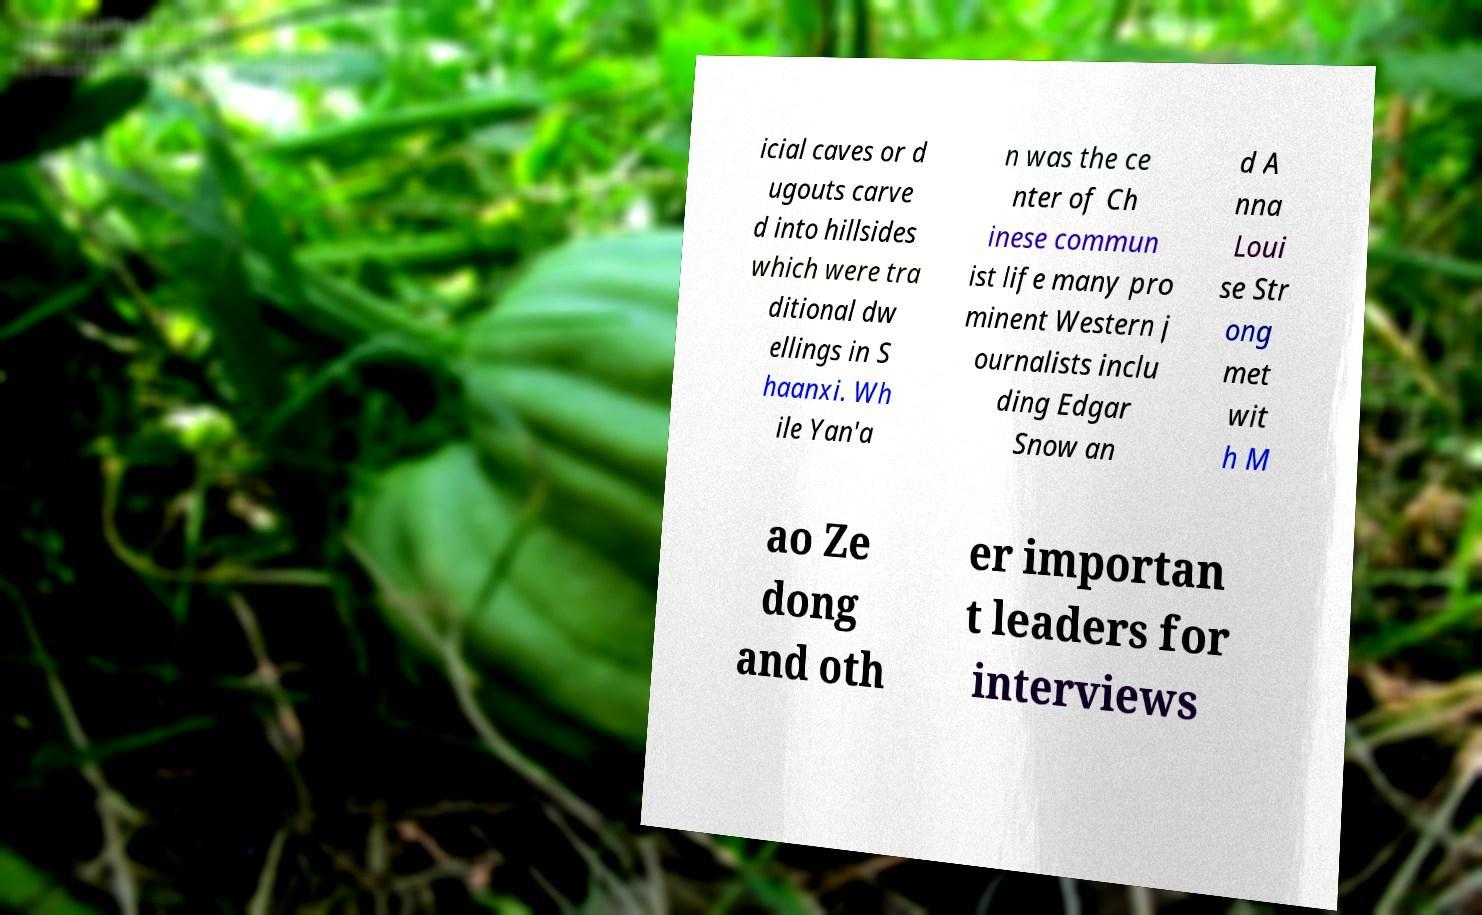Can you accurately transcribe the text from the provided image for me? icial caves or d ugouts carve d into hillsides which were tra ditional dw ellings in S haanxi. Wh ile Yan'a n was the ce nter of Ch inese commun ist life many pro minent Western j ournalists inclu ding Edgar Snow an d A nna Loui se Str ong met wit h M ao Ze dong and oth er importan t leaders for interviews 